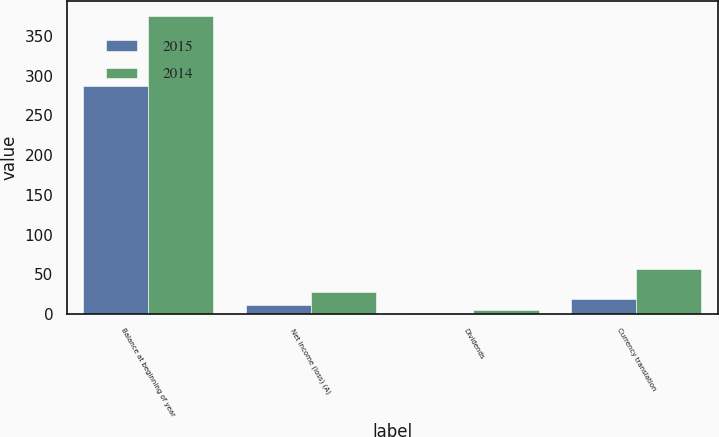Convert chart. <chart><loc_0><loc_0><loc_500><loc_500><stacked_bar_chart><ecel><fcel>Balance at beginning of year<fcel>Net income (loss) (A)<fcel>Dividends<fcel>Currency translation<nl><fcel>2015<fcel>287.2<fcel>11.5<fcel>2<fcel>18.8<nl><fcel>2014<fcel>375.8<fcel>27.4<fcel>4.7<fcel>56.5<nl></chart> 